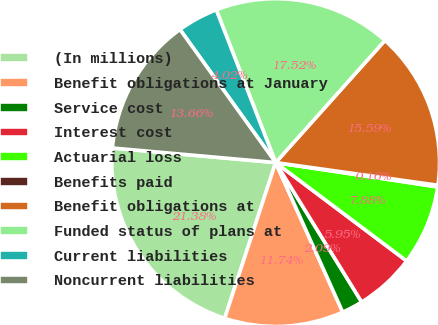<chart> <loc_0><loc_0><loc_500><loc_500><pie_chart><fcel>(In millions)<fcel>Benefit obligations at January<fcel>Service cost<fcel>Interest cost<fcel>Actuarial loss<fcel>Benefits paid<fcel>Benefit obligations at<fcel>Funded status of plans at<fcel>Current liabilities<fcel>Noncurrent liabilities<nl><fcel>21.38%<fcel>11.74%<fcel>2.09%<fcel>5.95%<fcel>7.88%<fcel>0.16%<fcel>15.59%<fcel>17.52%<fcel>4.02%<fcel>13.66%<nl></chart> 